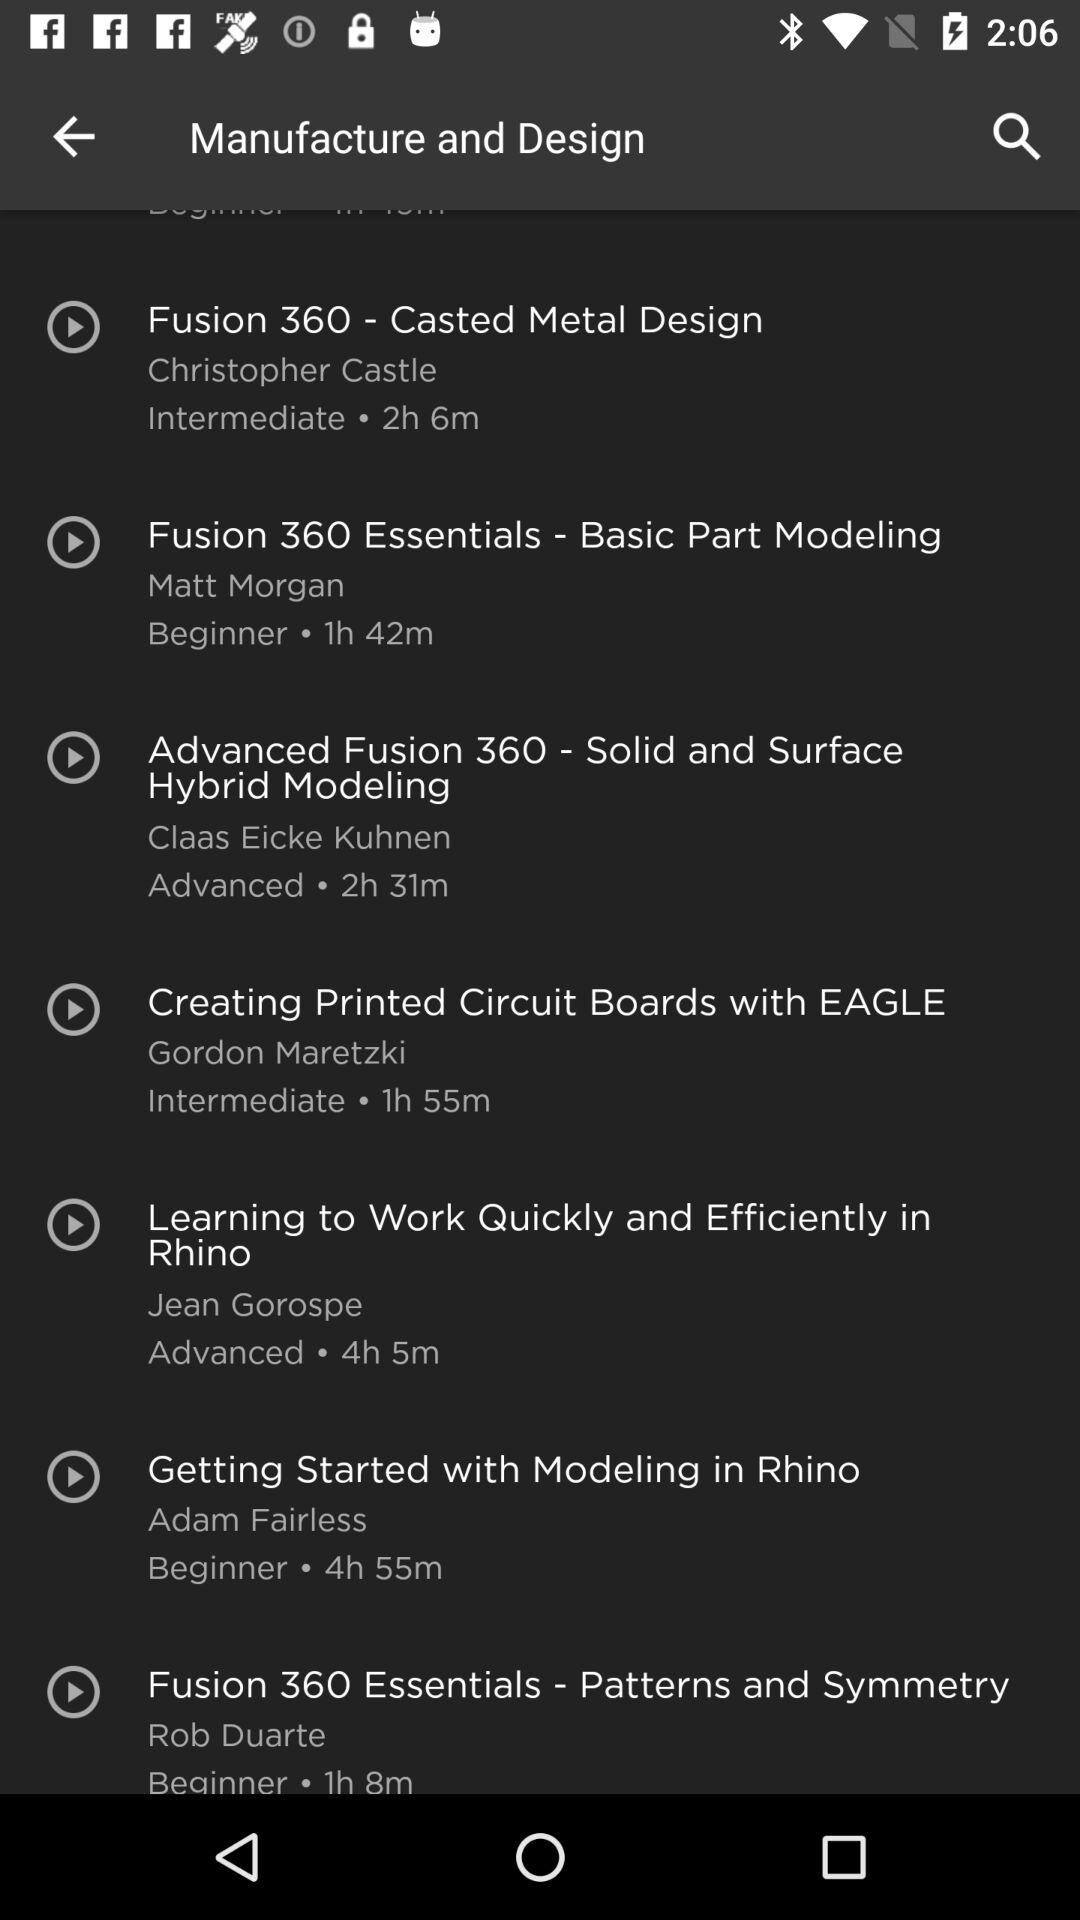What is the time duration of "Fusion 360 - Casted Metal Design"? The time duration is 2 hours 6 minutes. 